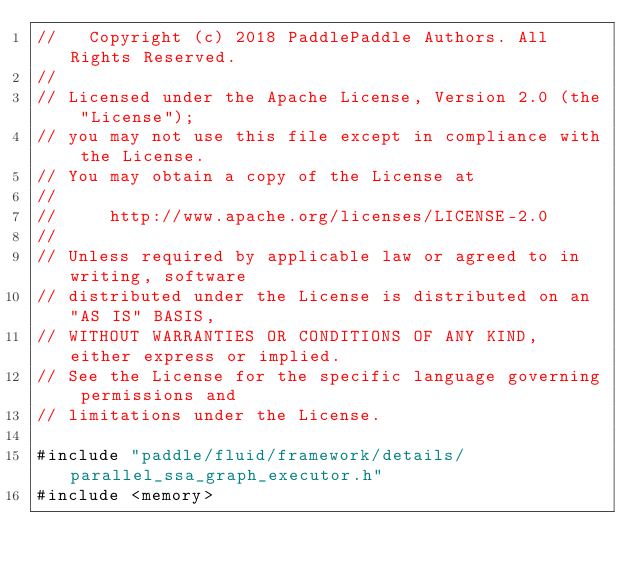<code> <loc_0><loc_0><loc_500><loc_500><_C++_>//   Copyright (c) 2018 PaddlePaddle Authors. All Rights Reserved.
//
// Licensed under the Apache License, Version 2.0 (the "License");
// you may not use this file except in compliance with the License.
// You may obtain a copy of the License at
//
//     http://www.apache.org/licenses/LICENSE-2.0
//
// Unless required by applicable law or agreed to in writing, software
// distributed under the License is distributed on an "AS IS" BASIS,
// WITHOUT WARRANTIES OR CONDITIONS OF ANY KIND, either express or implied.
// See the License for the specific language governing permissions and
// limitations under the License.

#include "paddle/fluid/framework/details/parallel_ssa_graph_executor.h"
#include <memory></code> 